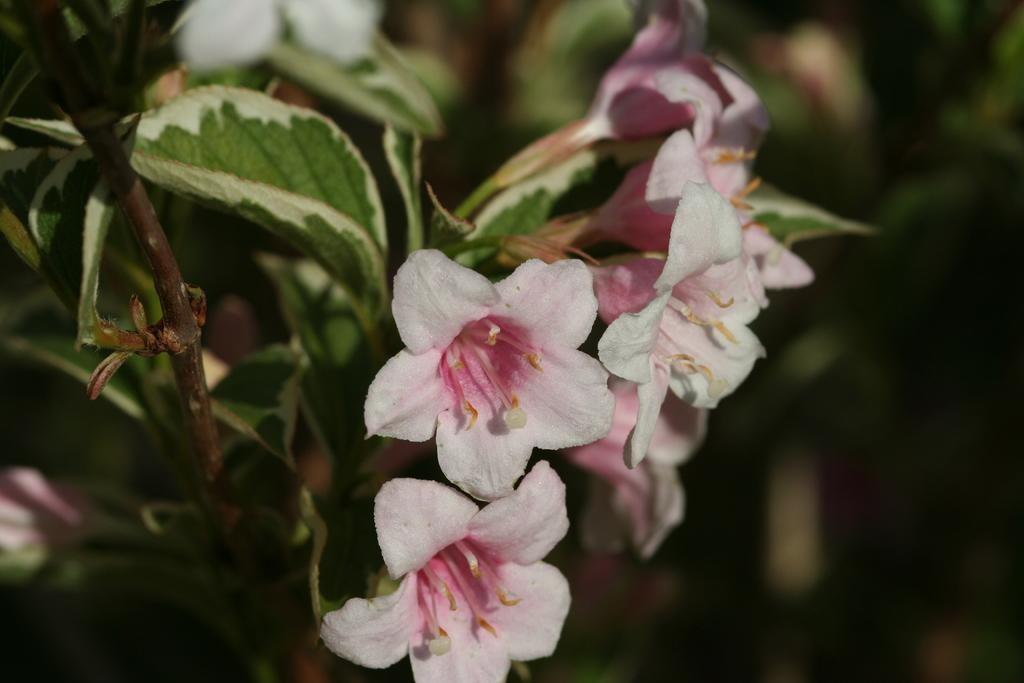What type of vegetation can be seen in the image? There are leaves and flowers in the image. Can you describe the background of the image? The background of the image is blurred. What type of holiday is being celebrated in the image? There is no indication of a holiday being celebrated in the image. How many parcels can be seen in the image? There are no parcels present in the image. 